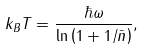Convert formula to latex. <formula><loc_0><loc_0><loc_500><loc_500>k _ { B } T = \frac { \hbar { \omega } } { \ln \left ( 1 + 1 / \bar { n } \right ) } ,</formula> 